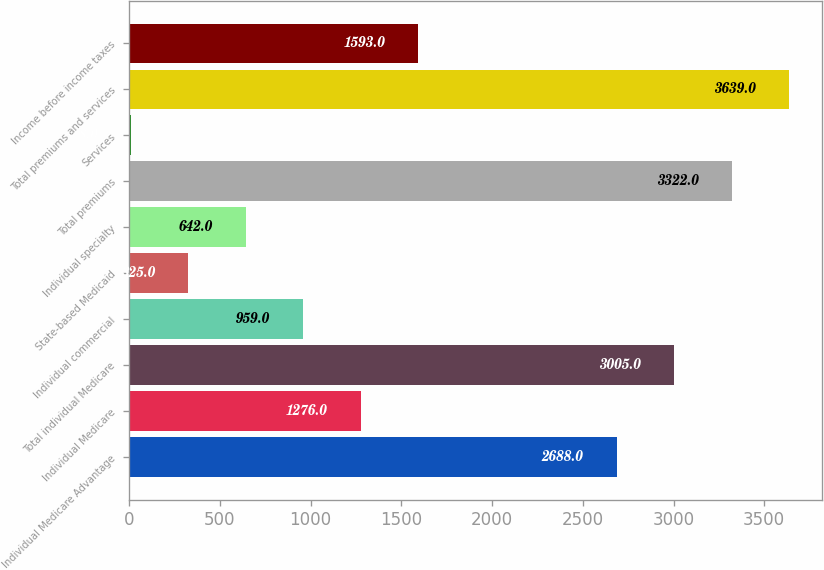Convert chart. <chart><loc_0><loc_0><loc_500><loc_500><bar_chart><fcel>Individual Medicare Advantage<fcel>Individual Medicare<fcel>Total individual Medicare<fcel>Individual commercial<fcel>State-based Medicaid<fcel>Individual specialty<fcel>Total premiums<fcel>Services<fcel>Total premiums and services<fcel>Income before income taxes<nl><fcel>2688<fcel>1276<fcel>3005<fcel>959<fcel>325<fcel>642<fcel>3322<fcel>8<fcel>3639<fcel>1593<nl></chart> 